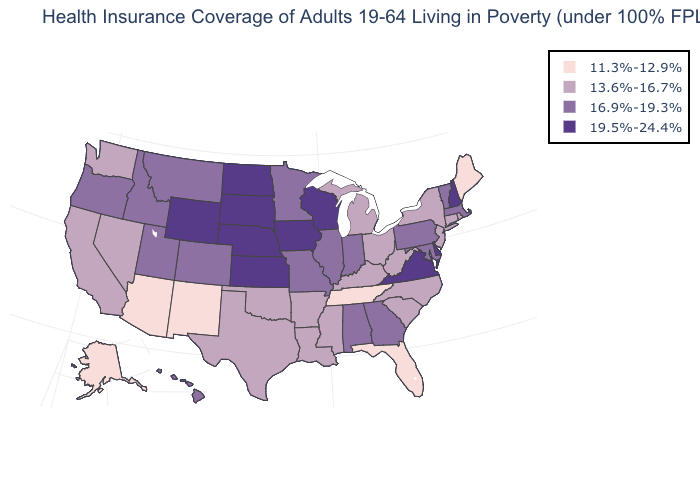Which states have the lowest value in the USA?
Answer briefly. Alaska, Arizona, Florida, Maine, New Mexico, Tennessee. What is the value of Maine?
Concise answer only. 11.3%-12.9%. Name the states that have a value in the range 13.6%-16.7%?
Keep it brief. Arkansas, California, Connecticut, Kentucky, Louisiana, Michigan, Mississippi, Nevada, New Jersey, New York, North Carolina, Ohio, Oklahoma, Rhode Island, South Carolina, Texas, Washington, West Virginia. What is the highest value in the USA?
Quick response, please. 19.5%-24.4%. Among the states that border North Dakota , does South Dakota have the highest value?
Concise answer only. Yes. What is the value of Wyoming?
Short answer required. 19.5%-24.4%. What is the highest value in the USA?
Answer briefly. 19.5%-24.4%. What is the value of Massachusetts?
Give a very brief answer. 16.9%-19.3%. What is the value of West Virginia?
Concise answer only. 13.6%-16.7%. What is the value of Utah?
Give a very brief answer. 16.9%-19.3%. Does Michigan have the highest value in the MidWest?
Answer briefly. No. What is the value of Utah?
Keep it brief. 16.9%-19.3%. What is the value of Arkansas?
Quick response, please. 13.6%-16.7%. What is the lowest value in the Northeast?
Concise answer only. 11.3%-12.9%. Does Washington have the highest value in the West?
Short answer required. No. 